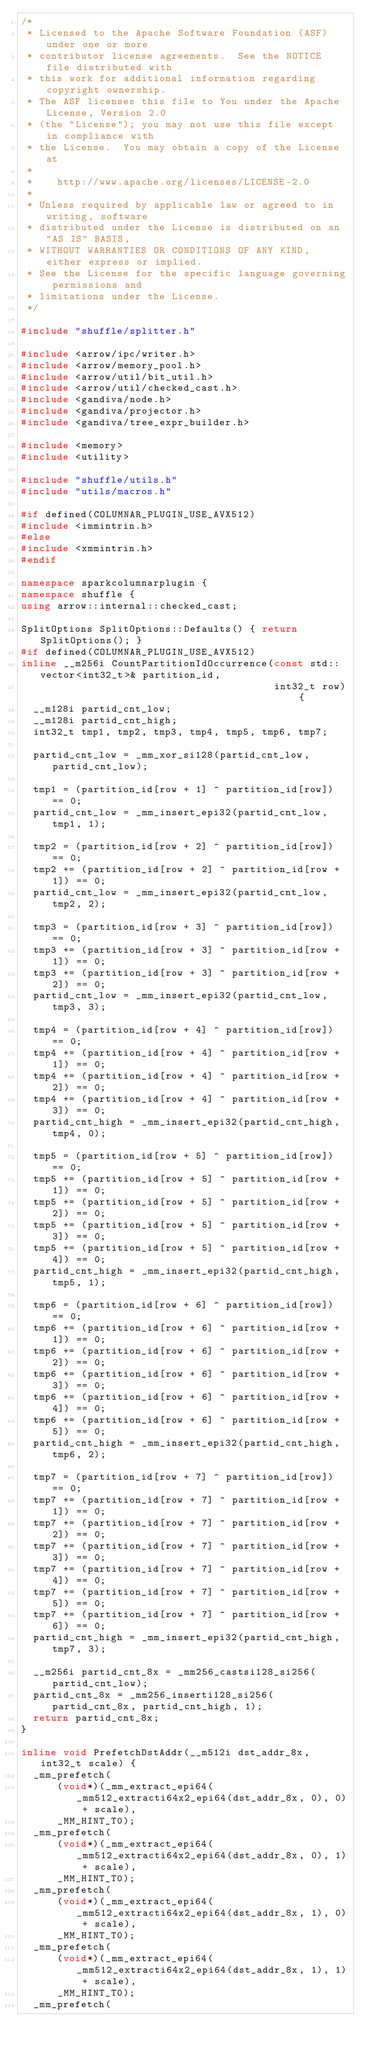Convert code to text. <code><loc_0><loc_0><loc_500><loc_500><_C++_>/*
 * Licensed to the Apache Software Foundation (ASF) under one or more
 * contributor license agreements.  See the NOTICE file distributed with
 * this work for additional information regarding copyright ownership.
 * The ASF licenses this file to You under the Apache License, Version 2.0
 * (the "License"); you may not use this file except in compliance with
 * the License.  You may obtain a copy of the License at
 *
 *    http://www.apache.org/licenses/LICENSE-2.0
 *
 * Unless required by applicable law or agreed to in writing, software
 * distributed under the License is distributed on an "AS IS" BASIS,
 * WITHOUT WARRANTIES OR CONDITIONS OF ANY KIND, either express or implied.
 * See the License for the specific language governing permissions and
 * limitations under the License.
 */

#include "shuffle/splitter.h"

#include <arrow/ipc/writer.h>
#include <arrow/memory_pool.h>
#include <arrow/util/bit_util.h>
#include <arrow/util/checked_cast.h>
#include <gandiva/node.h>
#include <gandiva/projector.h>
#include <gandiva/tree_expr_builder.h>

#include <memory>
#include <utility>

#include "shuffle/utils.h"
#include "utils/macros.h"

#if defined(COLUMNAR_PLUGIN_USE_AVX512)
#include <immintrin.h>
#else
#include <xmmintrin.h>
#endif

namespace sparkcolumnarplugin {
namespace shuffle {
using arrow::internal::checked_cast;

SplitOptions SplitOptions::Defaults() { return SplitOptions(); }
#if defined(COLUMNAR_PLUGIN_USE_AVX512)
inline __m256i CountPartitionIdOccurrence(const std::vector<int32_t>& partition_id,
                                          int32_t row) {
  __m128i partid_cnt_low;
  __m128i partid_cnt_high;
  int32_t tmp1, tmp2, tmp3, tmp4, tmp5, tmp6, tmp7;

  partid_cnt_low = _mm_xor_si128(partid_cnt_low, partid_cnt_low);

  tmp1 = (partition_id[row + 1] ^ partition_id[row]) == 0;
  partid_cnt_low = _mm_insert_epi32(partid_cnt_low, tmp1, 1);

  tmp2 = (partition_id[row + 2] ^ partition_id[row]) == 0;
  tmp2 += (partition_id[row + 2] ^ partition_id[row + 1]) == 0;
  partid_cnt_low = _mm_insert_epi32(partid_cnt_low, tmp2, 2);

  tmp3 = (partition_id[row + 3] ^ partition_id[row]) == 0;
  tmp3 += (partition_id[row + 3] ^ partition_id[row + 1]) == 0;
  tmp3 += (partition_id[row + 3] ^ partition_id[row + 2]) == 0;
  partid_cnt_low = _mm_insert_epi32(partid_cnt_low, tmp3, 3);

  tmp4 = (partition_id[row + 4] ^ partition_id[row]) == 0;
  tmp4 += (partition_id[row + 4] ^ partition_id[row + 1]) == 0;
  tmp4 += (partition_id[row + 4] ^ partition_id[row + 2]) == 0;
  tmp4 += (partition_id[row + 4] ^ partition_id[row + 3]) == 0;
  partid_cnt_high = _mm_insert_epi32(partid_cnt_high, tmp4, 0);

  tmp5 = (partition_id[row + 5] ^ partition_id[row]) == 0;
  tmp5 += (partition_id[row + 5] ^ partition_id[row + 1]) == 0;
  tmp5 += (partition_id[row + 5] ^ partition_id[row + 2]) == 0;
  tmp5 += (partition_id[row + 5] ^ partition_id[row + 3]) == 0;
  tmp5 += (partition_id[row + 5] ^ partition_id[row + 4]) == 0;
  partid_cnt_high = _mm_insert_epi32(partid_cnt_high, tmp5, 1);

  tmp6 = (partition_id[row + 6] ^ partition_id[row]) == 0;
  tmp6 += (partition_id[row + 6] ^ partition_id[row + 1]) == 0;
  tmp6 += (partition_id[row + 6] ^ partition_id[row + 2]) == 0;
  tmp6 += (partition_id[row + 6] ^ partition_id[row + 3]) == 0;
  tmp6 += (partition_id[row + 6] ^ partition_id[row + 4]) == 0;
  tmp6 += (partition_id[row + 6] ^ partition_id[row + 5]) == 0;
  partid_cnt_high = _mm_insert_epi32(partid_cnt_high, tmp6, 2);

  tmp7 = (partition_id[row + 7] ^ partition_id[row]) == 0;
  tmp7 += (partition_id[row + 7] ^ partition_id[row + 1]) == 0;
  tmp7 += (partition_id[row + 7] ^ partition_id[row + 2]) == 0;
  tmp7 += (partition_id[row + 7] ^ partition_id[row + 3]) == 0;
  tmp7 += (partition_id[row + 7] ^ partition_id[row + 4]) == 0;
  tmp7 += (partition_id[row + 7] ^ partition_id[row + 5]) == 0;
  tmp7 += (partition_id[row + 7] ^ partition_id[row + 6]) == 0;
  partid_cnt_high = _mm_insert_epi32(partid_cnt_high, tmp7, 3);

  __m256i partid_cnt_8x = _mm256_castsi128_si256(partid_cnt_low);
  partid_cnt_8x = _mm256_inserti128_si256(partid_cnt_8x, partid_cnt_high, 1);
  return partid_cnt_8x;
}

inline void PrefetchDstAddr(__m512i dst_addr_8x, int32_t scale) {
  _mm_prefetch(
      (void*)(_mm_extract_epi64(_mm512_extracti64x2_epi64(dst_addr_8x, 0), 0) + scale),
      _MM_HINT_T0);
  _mm_prefetch(
      (void*)(_mm_extract_epi64(_mm512_extracti64x2_epi64(dst_addr_8x, 0), 1) + scale),
      _MM_HINT_T0);
  _mm_prefetch(
      (void*)(_mm_extract_epi64(_mm512_extracti64x2_epi64(dst_addr_8x, 1), 0) + scale),
      _MM_HINT_T0);
  _mm_prefetch(
      (void*)(_mm_extract_epi64(_mm512_extracti64x2_epi64(dst_addr_8x, 1), 1) + scale),
      _MM_HINT_T0);
  _mm_prefetch(</code> 